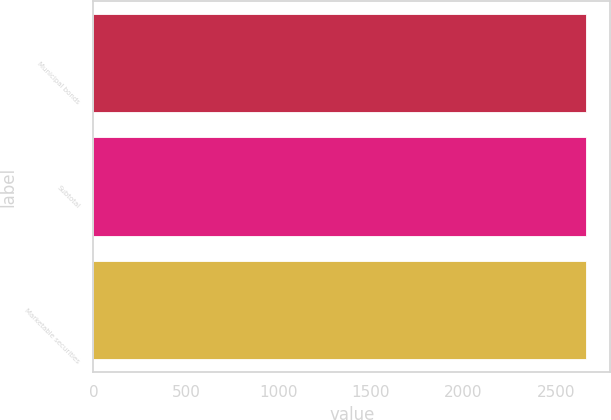Convert chart. <chart><loc_0><loc_0><loc_500><loc_500><bar_chart><fcel>Municipal bonds<fcel>Subtotal<fcel>Marketable securities<nl><fcel>2661<fcel>2661.1<fcel>2661.2<nl></chart> 